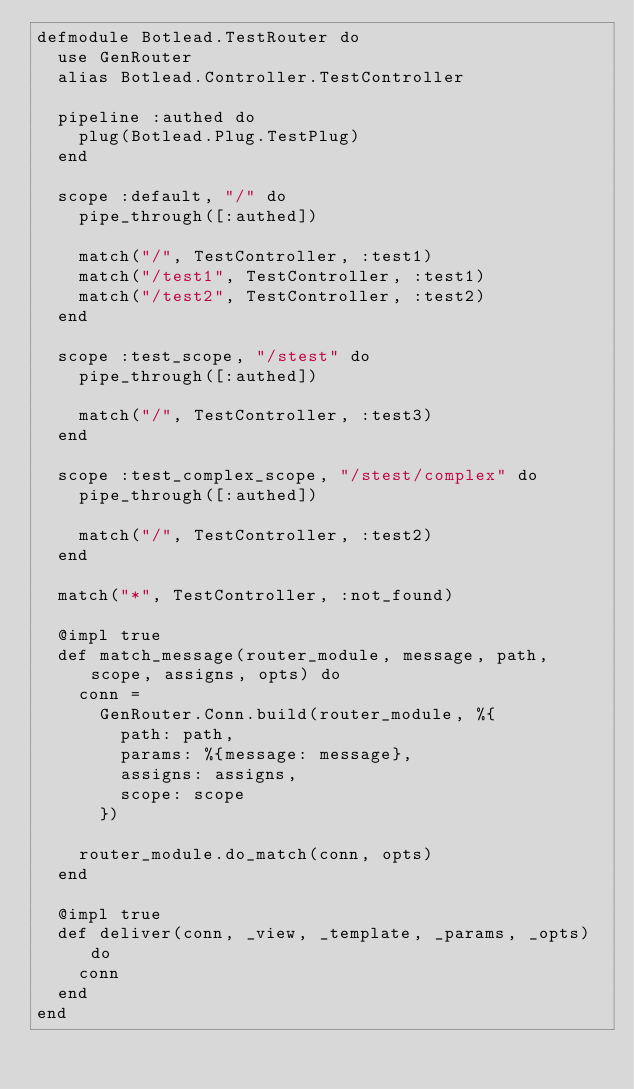<code> <loc_0><loc_0><loc_500><loc_500><_Elixir_>defmodule Botlead.TestRouter do
  use GenRouter
  alias Botlead.Controller.TestController

  pipeline :authed do
    plug(Botlead.Plug.TestPlug)
  end

  scope :default, "/" do
    pipe_through([:authed])

    match("/", TestController, :test1)
    match("/test1", TestController, :test1)
    match("/test2", TestController, :test2)
  end

  scope :test_scope, "/stest" do
    pipe_through([:authed])

    match("/", TestController, :test3)
  end

  scope :test_complex_scope, "/stest/complex" do
    pipe_through([:authed])

    match("/", TestController, :test2)
  end

  match("*", TestController, :not_found)

  @impl true
  def match_message(router_module, message, path, scope, assigns, opts) do
    conn =
      GenRouter.Conn.build(router_module, %{
        path: path,
        params: %{message: message},
        assigns: assigns,
        scope: scope
      })

    router_module.do_match(conn, opts)
  end

  @impl true
  def deliver(conn, _view, _template, _params, _opts) do
    conn
  end
end
</code> 